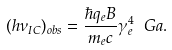<formula> <loc_0><loc_0><loc_500><loc_500>( h \nu _ { I C } ) _ { o b s } = \frac { \hbar { q } _ { e } B } { m _ { e } c } \gamma _ { e } ^ { 4 } \ G a .</formula> 